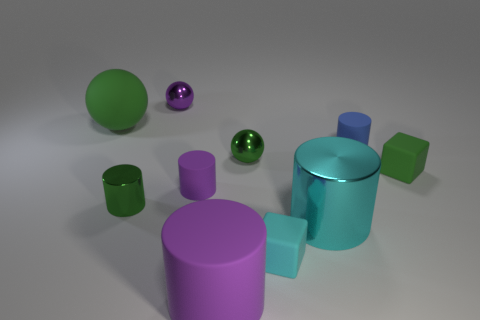Are there any other things that have the same size as the green rubber cube? Upon examining the image, we can observe that there are several objects of various sizes and colors. The green rubber cube is unique in its dimensions, and there does not appear to be another object of exactly the same size. 